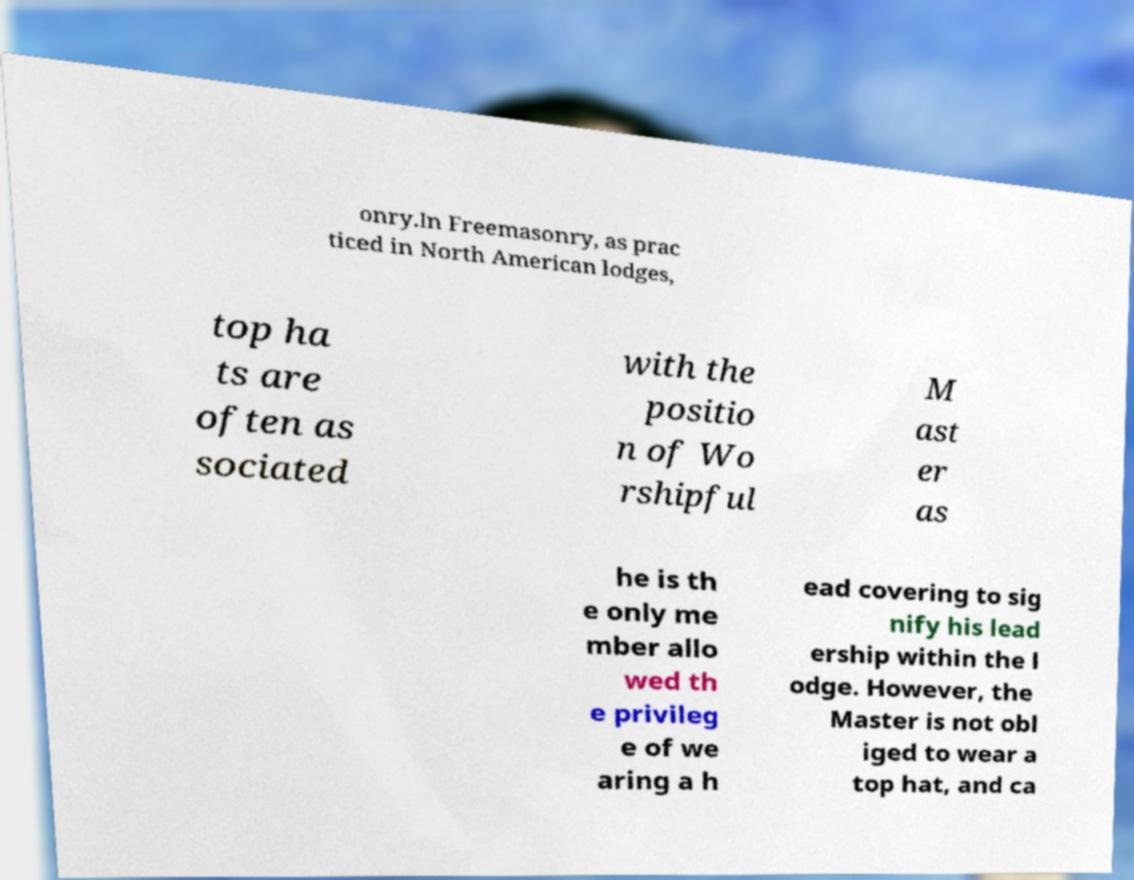Could you assist in decoding the text presented in this image and type it out clearly? onry.In Freemasonry, as prac ticed in North American lodges, top ha ts are often as sociated with the positio n of Wo rshipful M ast er as he is th e only me mber allo wed th e privileg e of we aring a h ead covering to sig nify his lead ership within the l odge. However, the Master is not obl iged to wear a top hat, and ca 